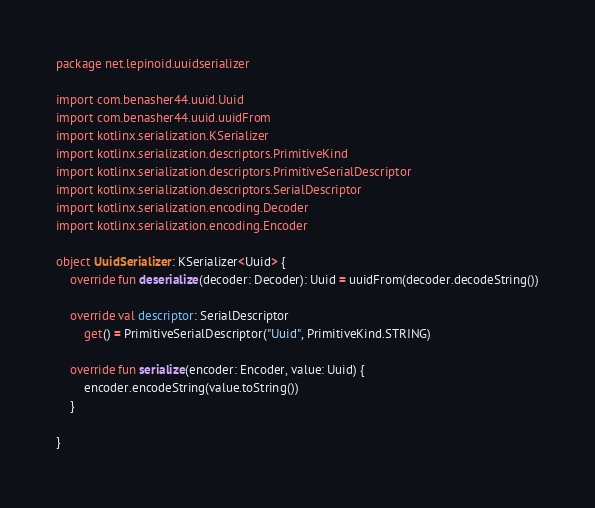Convert code to text. <code><loc_0><loc_0><loc_500><loc_500><_Kotlin_>package net.lepinoid.uuidserializer

import com.benasher44.uuid.Uuid
import com.benasher44.uuid.uuidFrom
import kotlinx.serialization.KSerializer
import kotlinx.serialization.descriptors.PrimitiveKind
import kotlinx.serialization.descriptors.PrimitiveSerialDescriptor
import kotlinx.serialization.descriptors.SerialDescriptor
import kotlinx.serialization.encoding.Decoder
import kotlinx.serialization.encoding.Encoder

object UuidSerializer: KSerializer<Uuid> {
    override fun deserialize(decoder: Decoder): Uuid = uuidFrom(decoder.decodeString())

    override val descriptor: SerialDescriptor
        get() = PrimitiveSerialDescriptor("Uuid", PrimitiveKind.STRING)

    override fun serialize(encoder: Encoder, value: Uuid) {
        encoder.encodeString(value.toString())
    }

}</code> 